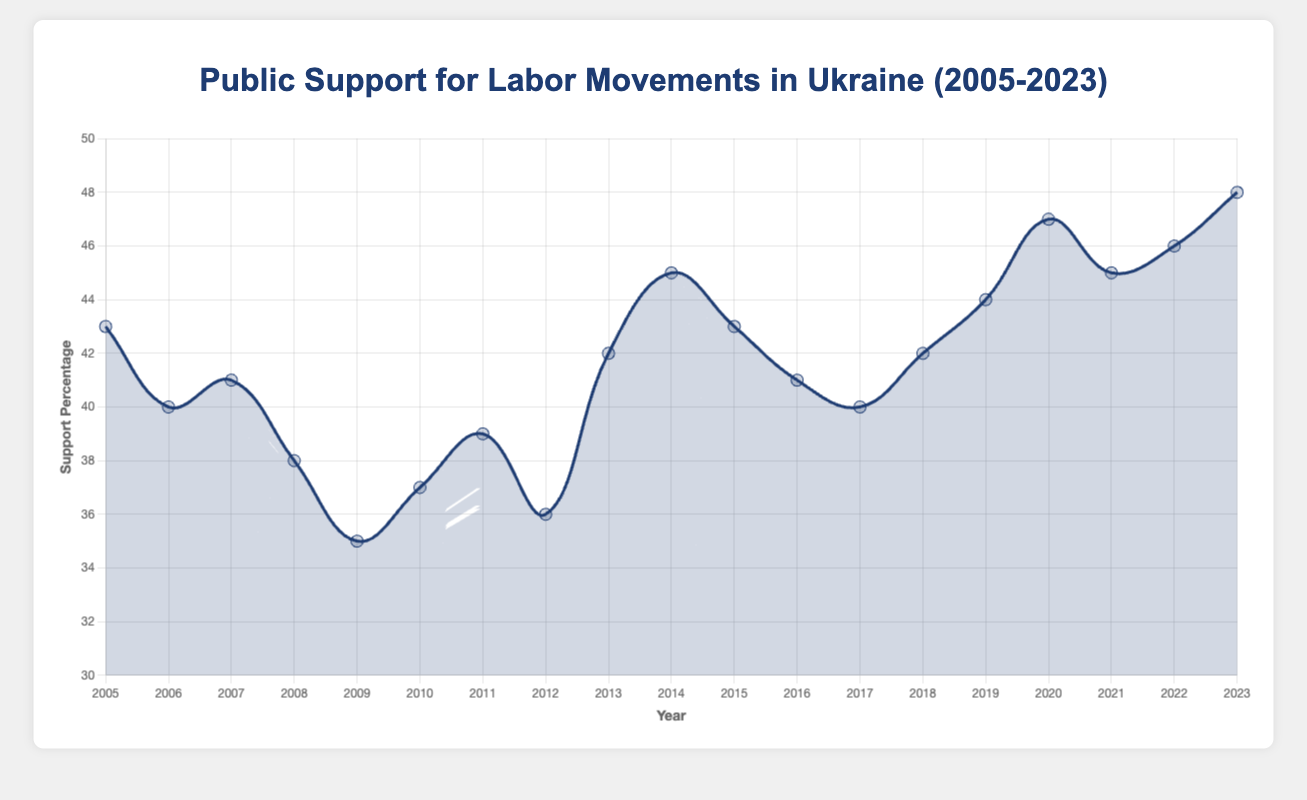What is the highest level of public support for labor movements recorded between 2005 and 2023? The highest level of public support can be identified by looking for the maximum point on the curve. The highest recorded support percentage is at the year 2023, with a percentage of 48.
Answer: 48% How did public support change from 2008 to 2009? To determine the change, subtract the support percentage in 2009 from that in 2008. The support in 2008 is 38%, and in 2009 it is 35%. Therefore, the change is 38% - 35% = 3%.
Answer: Decreased by 3% What is the average public support between 2015 and 2020? To find the average, sum the support percentages for the years 2015, 2016, 2017, 2018, 2019, and 2020, then divide by 6. The values are 43, 41, 40, 42, 44, and 47 respectively. The sum is 257, and dividing by 6 gives approximately 42.83%.
Answer: 42.83% Which year witnessed the largest year-on-year increase in public support? Inspecting the differences between consecutive years, the largest increase is observed between 2019 and 2020, increasing from 44% to 47%. The increase is 47% - 44% = 3%.
Answer: 2020 Did public support ever drop consecutively for more than one year? We need to check for consecutive decreases. From 2005 to 2006 to 2007, support dropped consecutively from 43% to 40%, then 40% to 41%. Another consecutive decrease happened from 2011 to 2012, from 39% to 36%.
Answer: Yes What was the level of public support during the Euromaidan Movement in 2013, and how much did it increase compared to 2012? In 2013, the support was 42%. In 2012, it was 36%. The increase is calculated as 42% - 36% = 6%.
Answer: 42%, increased by 6% Compare public support levels in 2014 and 2015. Which year had higher support, and by how much? In 2014, the support was 45%, and in 2015 it was 43%. The difference is 45% - 43% = 2%. Therefore, 2014 had higher support by 2%.
Answer: 2014, by 2% What is the median level of public support from 2005 to 2023? To find the median, list all values and select the middle one. The support percentages are [35, 36, 37, 38, 39, 40, 40, 41, 41, 42, 42, 43, 43, 44, 45, 45, 46, 47, 48]. The middle value in this sorted list is 42%.
Answer: 42% What was the level of public support before the impact of the COVID-19 pandemic started in 2020? The level of support in 2019 right before the COVID-19 pandemic started is 44%.
Answer: 44% How does the lowest recorded public support compare with the highest recorded support within the given timeline? The lowest recorded support percentage is 35% in 2009, and the highest is 48% in 2023. The difference is 48% - 35% = 13%.
Answer: 13% 